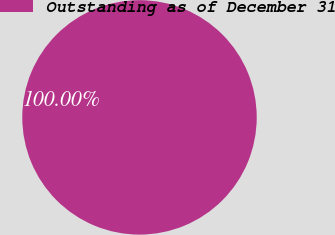Convert chart. <chart><loc_0><loc_0><loc_500><loc_500><pie_chart><fcel>Outstanding as of December 31<nl><fcel>100.0%<nl></chart> 